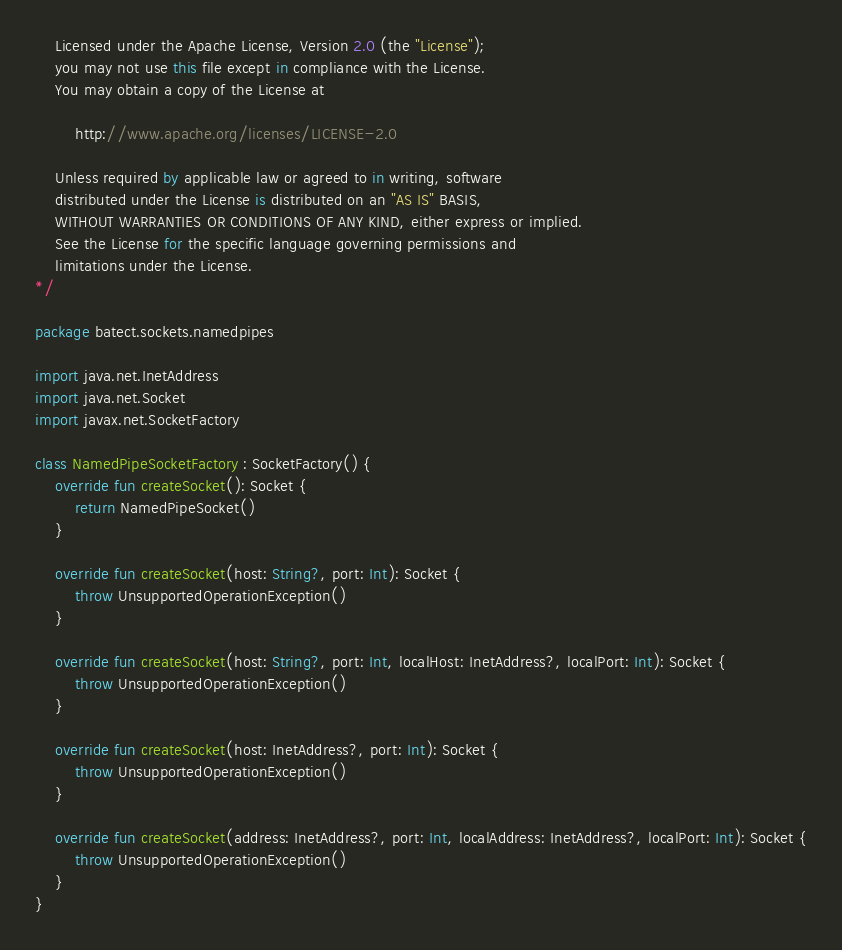<code> <loc_0><loc_0><loc_500><loc_500><_Kotlin_>    Licensed under the Apache License, Version 2.0 (the "License");
    you may not use this file except in compliance with the License.
    You may obtain a copy of the License at

        http://www.apache.org/licenses/LICENSE-2.0

    Unless required by applicable law or agreed to in writing, software
    distributed under the License is distributed on an "AS IS" BASIS,
    WITHOUT WARRANTIES OR CONDITIONS OF ANY KIND, either express or implied.
    See the License for the specific language governing permissions and
    limitations under the License.
*/

package batect.sockets.namedpipes

import java.net.InetAddress
import java.net.Socket
import javax.net.SocketFactory

class NamedPipeSocketFactory : SocketFactory() {
    override fun createSocket(): Socket {
        return NamedPipeSocket()
    }

    override fun createSocket(host: String?, port: Int): Socket {
        throw UnsupportedOperationException()
    }

    override fun createSocket(host: String?, port: Int, localHost: InetAddress?, localPort: Int): Socket {
        throw UnsupportedOperationException()
    }

    override fun createSocket(host: InetAddress?, port: Int): Socket {
        throw UnsupportedOperationException()
    }

    override fun createSocket(address: InetAddress?, port: Int, localAddress: InetAddress?, localPort: Int): Socket {
        throw UnsupportedOperationException()
    }
}
</code> 